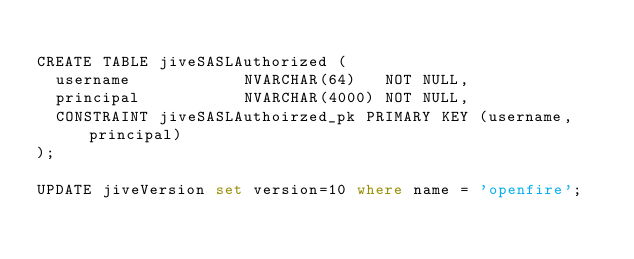Convert code to text. <code><loc_0><loc_0><loc_500><loc_500><_SQL_>
CREATE TABLE jiveSASLAuthorized (
  username            NVARCHAR(64)   NOT NULL,
  principal           NVARCHAR(4000) NOT NULL,
  CONSTRAINT jiveSASLAuthoirzed_pk PRIMARY KEY (username, principal)
);

UPDATE jiveVersion set version=10 where name = 'openfire';
</code> 